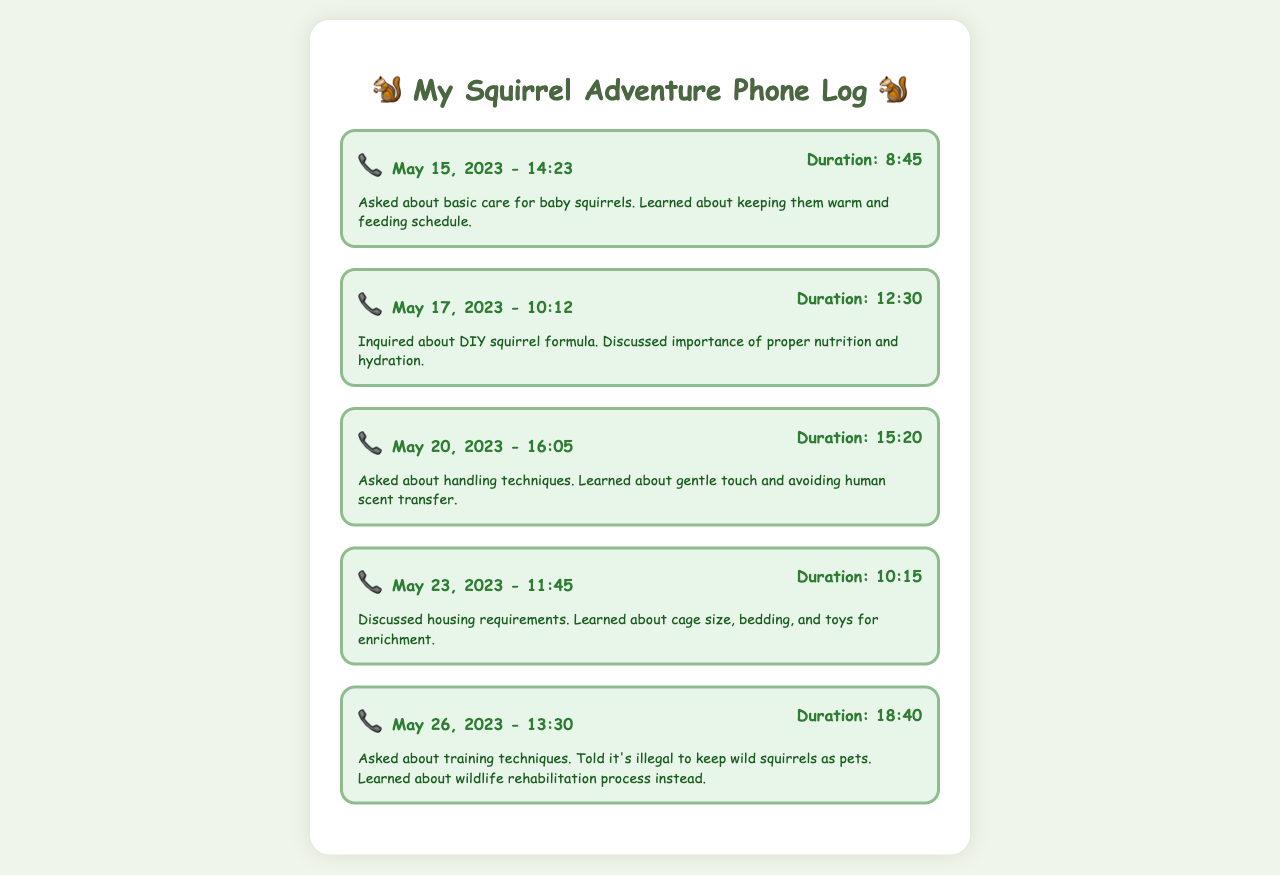what is the date of the first call? The date of the first call is given in the document as May 15, 2023.
Answer: May 15, 2023 how long was the longest call? The document lists the call durations, with the longest call being 18 minutes and 40 seconds.
Answer: 18:40 what topic was discussed on May 23, 2023? The document states that on May 23, 2023, the discussion was about housing requirements for squirrels.
Answer: housing requirements how many calls were made in total? The document provides five separate call records indicating the total number of calls.
Answer: 5 what technique was emphasized for handling squirrels? The document mentions that a gentle touch is important when handling squirrels.
Answer: gentle touch what is illegal according to the last call? In the last call, it was mentioned that keeping wild squirrels as pets is illegal.
Answer: illegal to keep wild squirrels as pets what was one thing learned about the DIY squirrel formula? The document explains that the proper nutrition and hydration is important when discussing DIY squirrel formula.
Answer: proper nutrition what aspect of squirrel care was discussed on May 20, 2023? The call on May 20, 2023 focused on handling techniques for squirrels.
Answer: handling techniques 